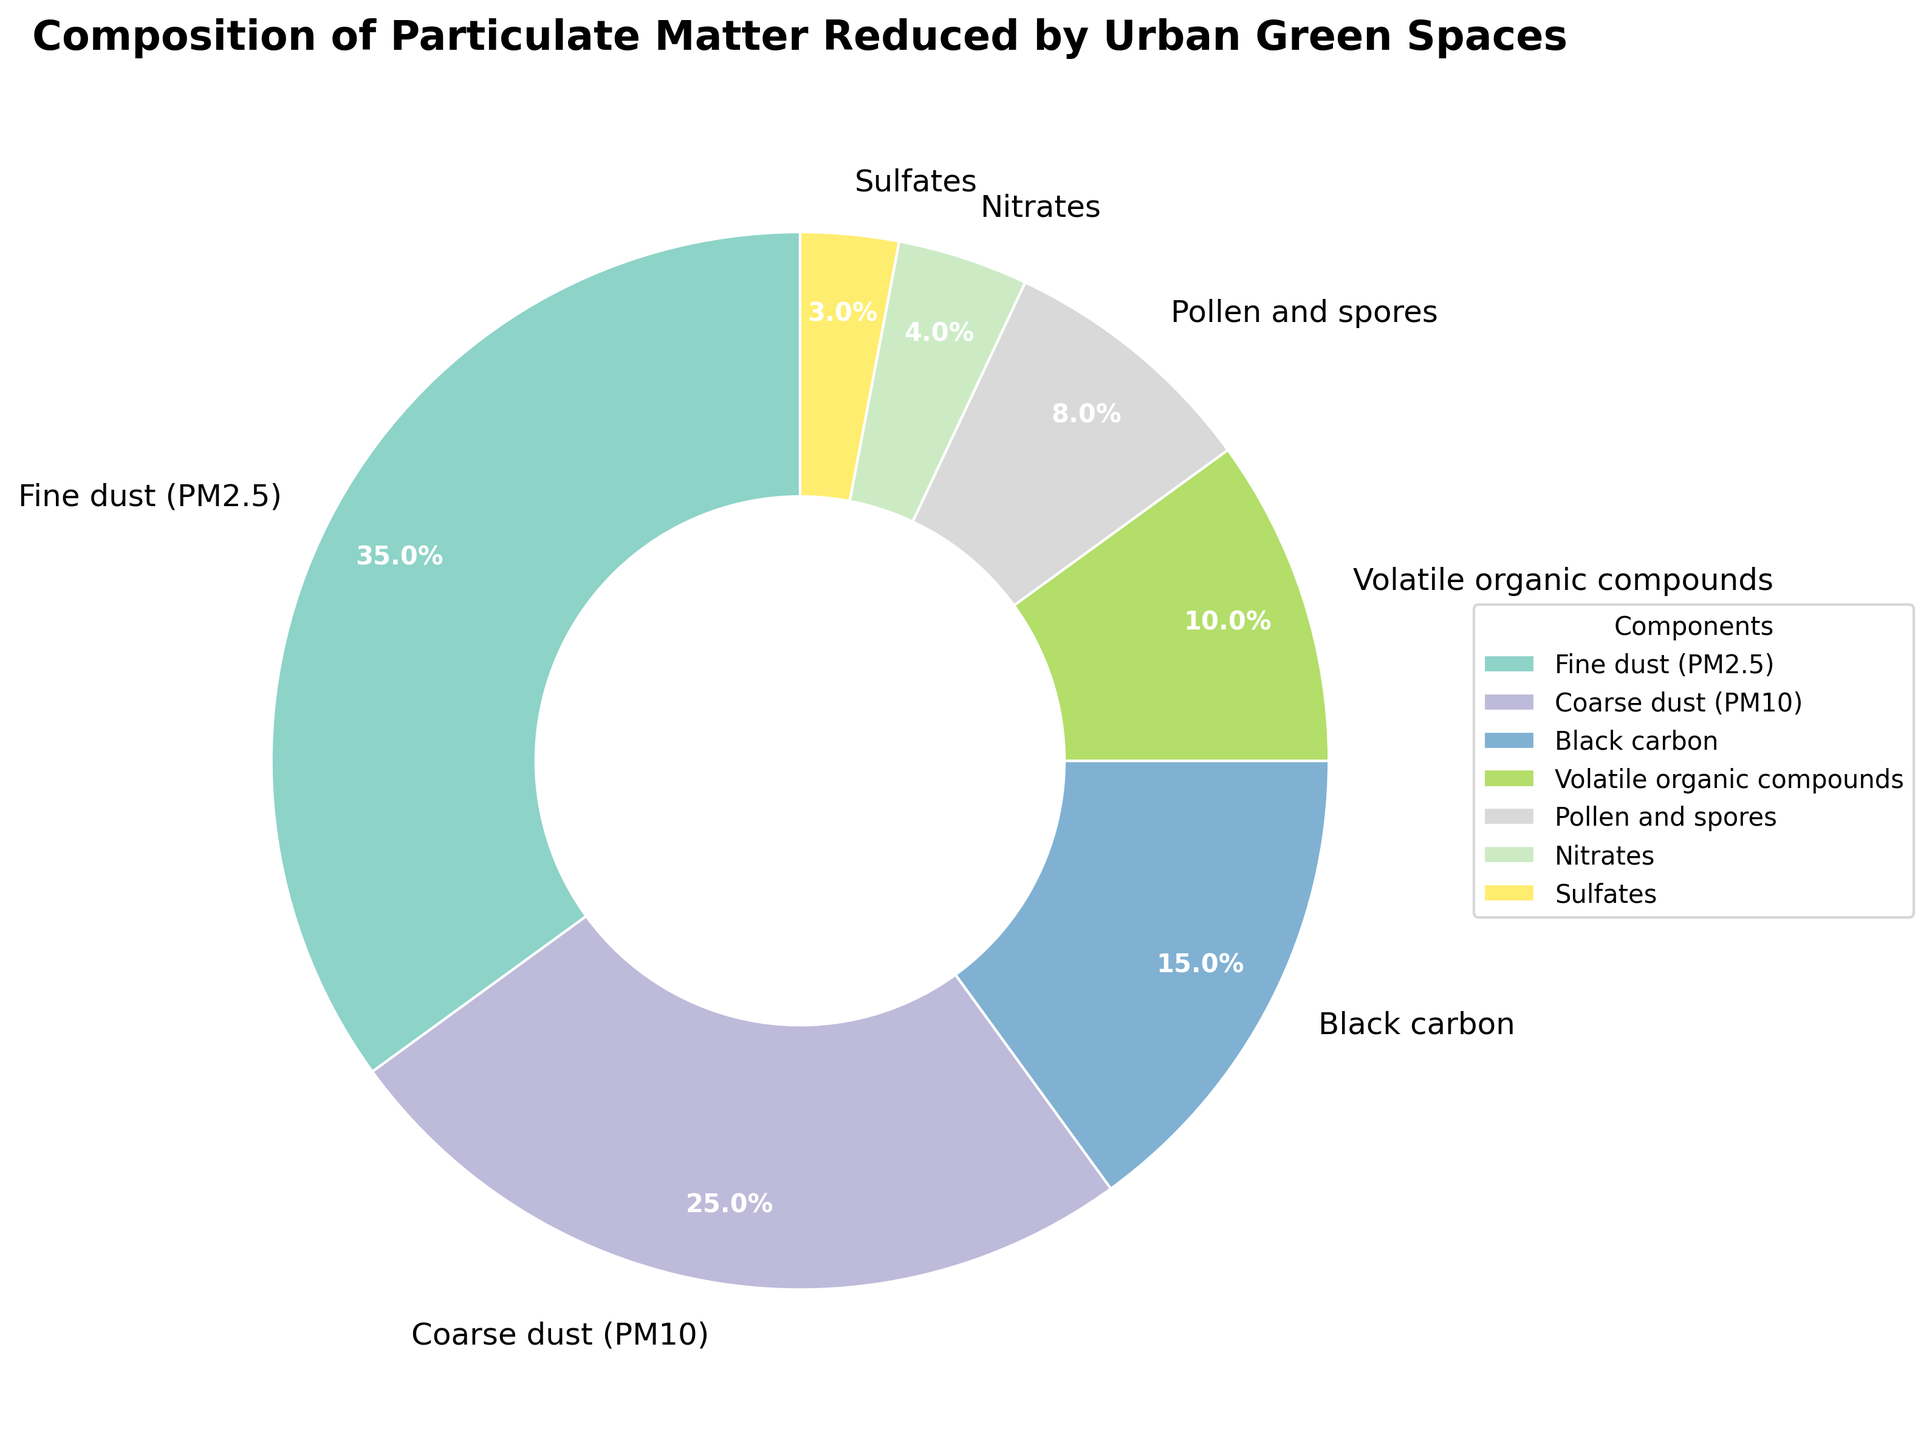Which component has the highest percentage? The component with the highest percentage is the one that takes up the largest section of the pie chart. In this case, Fine dust (PM2.5) has the largest section.
Answer: Fine dust (PM2.5) What is the combined percentage of Fine dust (PM2.5) and Coarse dust (PM10)? To find the combined percentage, add the percentages of Fine dust (PM2.5) and Coarse dust (PM10): 35% + 25% = 60%.
Answer: 60% How does the percentage of Volatile organic compounds compare to Black carbon? Volatile organic compounds have a percentage of 10% and Black carbon has 15%. Since 10% is less than 15%, Volatile organic compounds contribute less.
Answer: Volatile organic compounds have a lower percentage Which two components together have the same percentage as Coarse dust (PM10)? To find the two components whose combined percentage equals Coarse dust (PM10), which is 25%, we look for two components that add up to 25%. Nitrates (4%) and Volatile organic compounds (10%) together add up to 14%. Nitrates (4%) and Pollen and spores (8%) add up to 12%. Pollen and spores (8%) and Volatile organic compounds (10%) add up to 18%. However, Black carbon (15%) and Sulfates (3%) together add up to 18%, which isn't equal. So, only Volatile organic compounds (10%) and Nitrates (4%) both make up less than 25% together.
Answer: Not possible Which component is directly placed after Pollen and spores in the legend? In the legend, the components are listed in the order they are in the pie chart. After Pollen and spores, which is listed fifth, Sulfates, listed sixth, follow.
Answer: Sulfates What is the percentage difference between Fine dust (PM2.5) and Sulfates? The percentage of Fine dust (PM2.5) is 35% and that of Sulfates is 3%. The difference is calculated as 35% - 3% = 32%.
Answer: 32% What is the ratio of the percentage of Coarse dust (PM10) to Black carbon? The percentage of Coarse dust (PM10) is 25% and that of Black carbon is 15%. The ratio can be calculated as 25% / 15%, which simplifies to approximately 1.67.
Answer: 1.67 Which components make up less than 10% of the pie chart? To identify components that make up less than 10%, we look at the percentages: Black carbon (15%), Volatile organic compounds (10%), Pollen and spores (8%), Nitrates (4%), and Sulfates (3%). Pollen and spores, Nitrates, and Sulfates are each less than 10%.
Answer: Pollen and spores, Nitrates, Sulfates If the section for Fine dust (PM2.5) were removed, what would be the new combined percentage for all remaining components? Removing Fine dust (PM2.5) means subtracting its percentage (35%) from the total (100%). Thus, the new combined percentage is 100% - 35% = 65%.
Answer: 65% What visual attribute differentiates the component with the lowest percentage? The component with the lowest percentage, Sulfates, can be identified visually by its smaller wedge size in the pie chart.
Answer: Smaller wedge size 